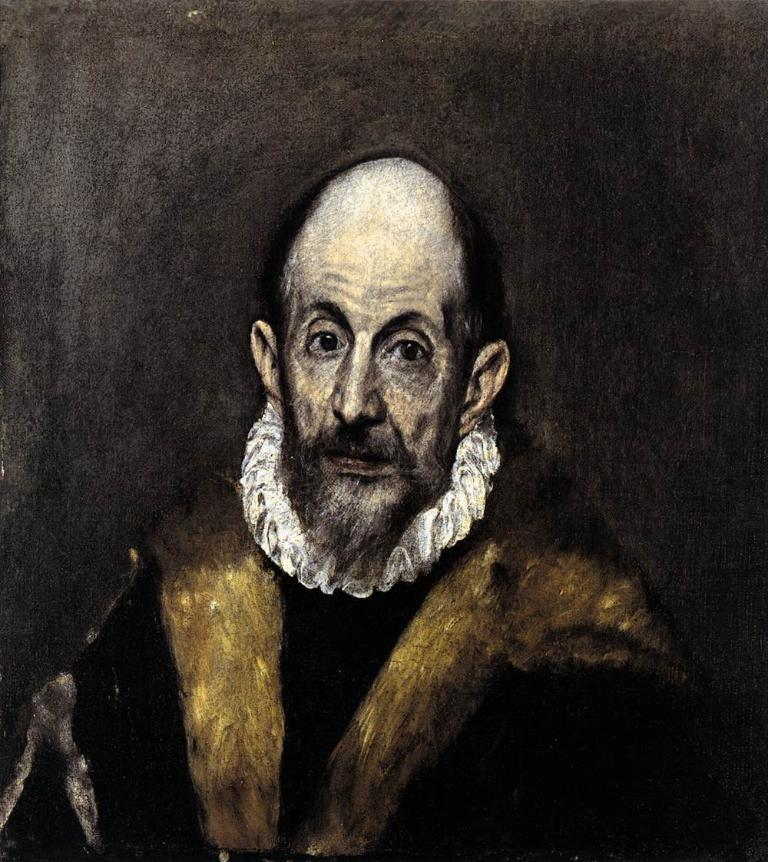What is depicted in the image? There is a painting of a person in the image. What is the painting placed on or attached to? The painting is on an object. Are there any visible cobwebs around the painting in the image? There is no mention of cobwebs in the provided facts, so we cannot determine if any are present in the image. 